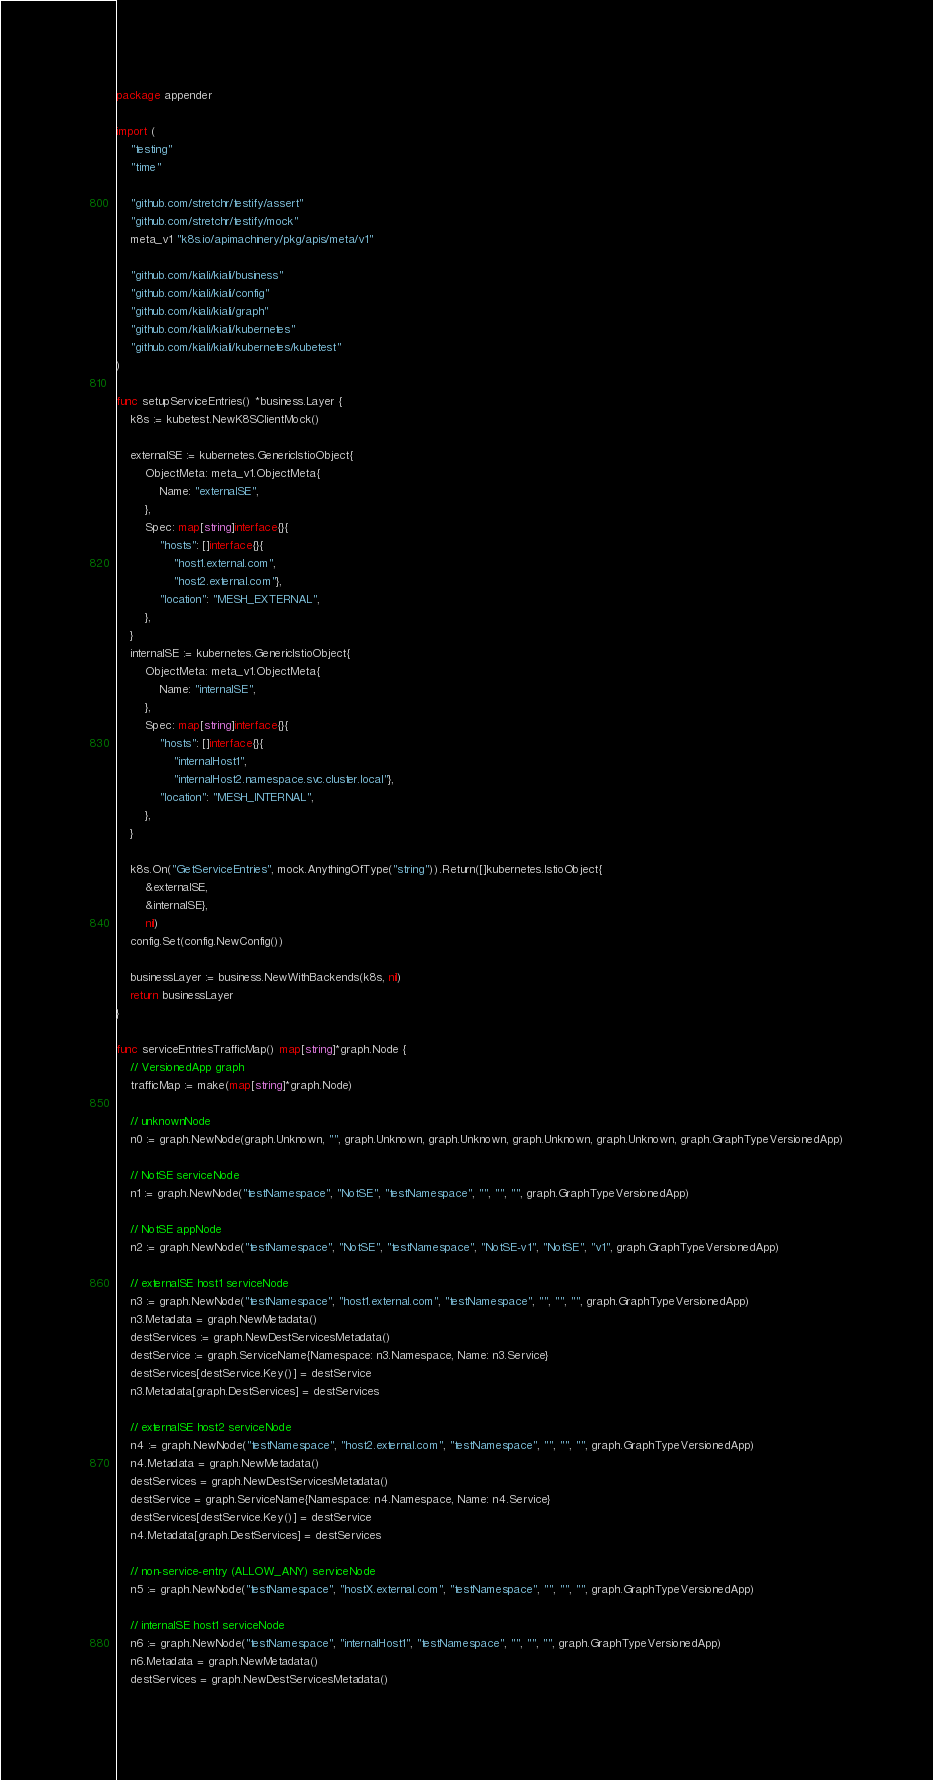<code> <loc_0><loc_0><loc_500><loc_500><_Go_>package appender

import (
	"testing"
	"time"

	"github.com/stretchr/testify/assert"
	"github.com/stretchr/testify/mock"
	meta_v1 "k8s.io/apimachinery/pkg/apis/meta/v1"

	"github.com/kiali/kiali/business"
	"github.com/kiali/kiali/config"
	"github.com/kiali/kiali/graph"
	"github.com/kiali/kiali/kubernetes"
	"github.com/kiali/kiali/kubernetes/kubetest"
)

func setupServiceEntries() *business.Layer {
	k8s := kubetest.NewK8SClientMock()

	externalSE := kubernetes.GenericIstioObject{
		ObjectMeta: meta_v1.ObjectMeta{
			Name: "externalSE",
		},
		Spec: map[string]interface{}{
			"hosts": []interface{}{
				"host1.external.com",
				"host2.external.com"},
			"location": "MESH_EXTERNAL",
		},
	}
	internalSE := kubernetes.GenericIstioObject{
		ObjectMeta: meta_v1.ObjectMeta{
			Name: "internalSE",
		},
		Spec: map[string]interface{}{
			"hosts": []interface{}{
				"internalHost1",
				"internalHost2.namespace.svc.cluster.local"},
			"location": "MESH_INTERNAL",
		},
	}

	k8s.On("GetServiceEntries", mock.AnythingOfType("string")).Return([]kubernetes.IstioObject{
		&externalSE,
		&internalSE},
		nil)
	config.Set(config.NewConfig())

	businessLayer := business.NewWithBackends(k8s, nil)
	return businessLayer
}

func serviceEntriesTrafficMap() map[string]*graph.Node {
	// VersionedApp graph
	trafficMap := make(map[string]*graph.Node)

	// unknownNode
	n0 := graph.NewNode(graph.Unknown, "", graph.Unknown, graph.Unknown, graph.Unknown, graph.Unknown, graph.GraphTypeVersionedApp)

	// NotSE serviceNode
	n1 := graph.NewNode("testNamespace", "NotSE", "testNamespace", "", "", "", graph.GraphTypeVersionedApp)

	// NotSE appNode
	n2 := graph.NewNode("testNamespace", "NotSE", "testNamespace", "NotSE-v1", "NotSE", "v1", graph.GraphTypeVersionedApp)

	// externalSE host1 serviceNode
	n3 := graph.NewNode("testNamespace", "host1.external.com", "testNamespace", "", "", "", graph.GraphTypeVersionedApp)
	n3.Metadata = graph.NewMetadata()
	destServices := graph.NewDestServicesMetadata()
	destService := graph.ServiceName{Namespace: n3.Namespace, Name: n3.Service}
	destServices[destService.Key()] = destService
	n3.Metadata[graph.DestServices] = destServices

	// externalSE host2 serviceNode
	n4 := graph.NewNode("testNamespace", "host2.external.com", "testNamespace", "", "", "", graph.GraphTypeVersionedApp)
	n4.Metadata = graph.NewMetadata()
	destServices = graph.NewDestServicesMetadata()
	destService = graph.ServiceName{Namespace: n4.Namespace, Name: n4.Service}
	destServices[destService.Key()] = destService
	n4.Metadata[graph.DestServices] = destServices

	// non-service-entry (ALLOW_ANY) serviceNode
	n5 := graph.NewNode("testNamespace", "hostX.external.com", "testNamespace", "", "", "", graph.GraphTypeVersionedApp)

	// internalSE host1 serviceNode
	n6 := graph.NewNode("testNamespace", "internalHost1", "testNamespace", "", "", "", graph.GraphTypeVersionedApp)
	n6.Metadata = graph.NewMetadata()
	destServices = graph.NewDestServicesMetadata()</code> 